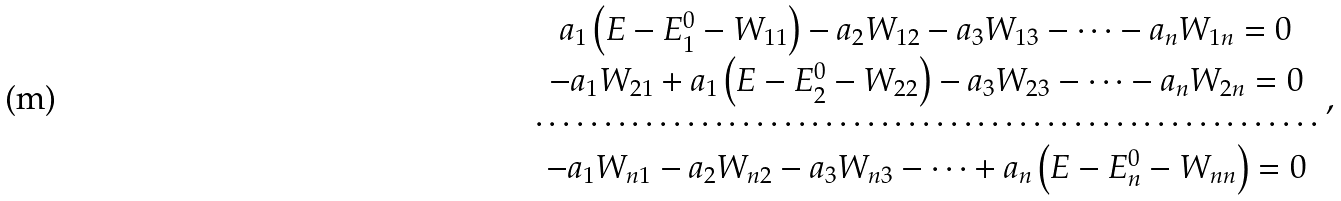<formula> <loc_0><loc_0><loc_500><loc_500>\begin{array} { c } a _ { 1 } \left ( E - E _ { 1 } ^ { 0 } - W _ { 1 1 } \right ) - a _ { 2 } W _ { 1 2 } - a _ { 3 } W _ { 1 3 } - \dots - a _ { n } W _ { 1 n } = 0 \\ - a _ { 1 } W _ { 2 1 } + a _ { 1 } \left ( E - E _ { 2 } ^ { 0 } - W _ { 2 2 } \right ) - a _ { 3 } W _ { 2 3 } - \dots - a _ { n } W _ { 2 n } = 0 \\ \cdots \cdots \cdots \cdots \cdots \cdots \cdots \cdots \cdots \cdots \cdots \cdots \cdots \cdots \cdots \cdots \cdots \cdots \cdots \\ - a _ { 1 } W _ { n 1 } - a _ { 2 } W _ { n 2 } - a _ { 3 } W _ { n 3 } - \dots + a _ { n } \left ( E - E _ { n } ^ { 0 } - W _ { n n } \right ) = 0 \end{array} ,</formula> 